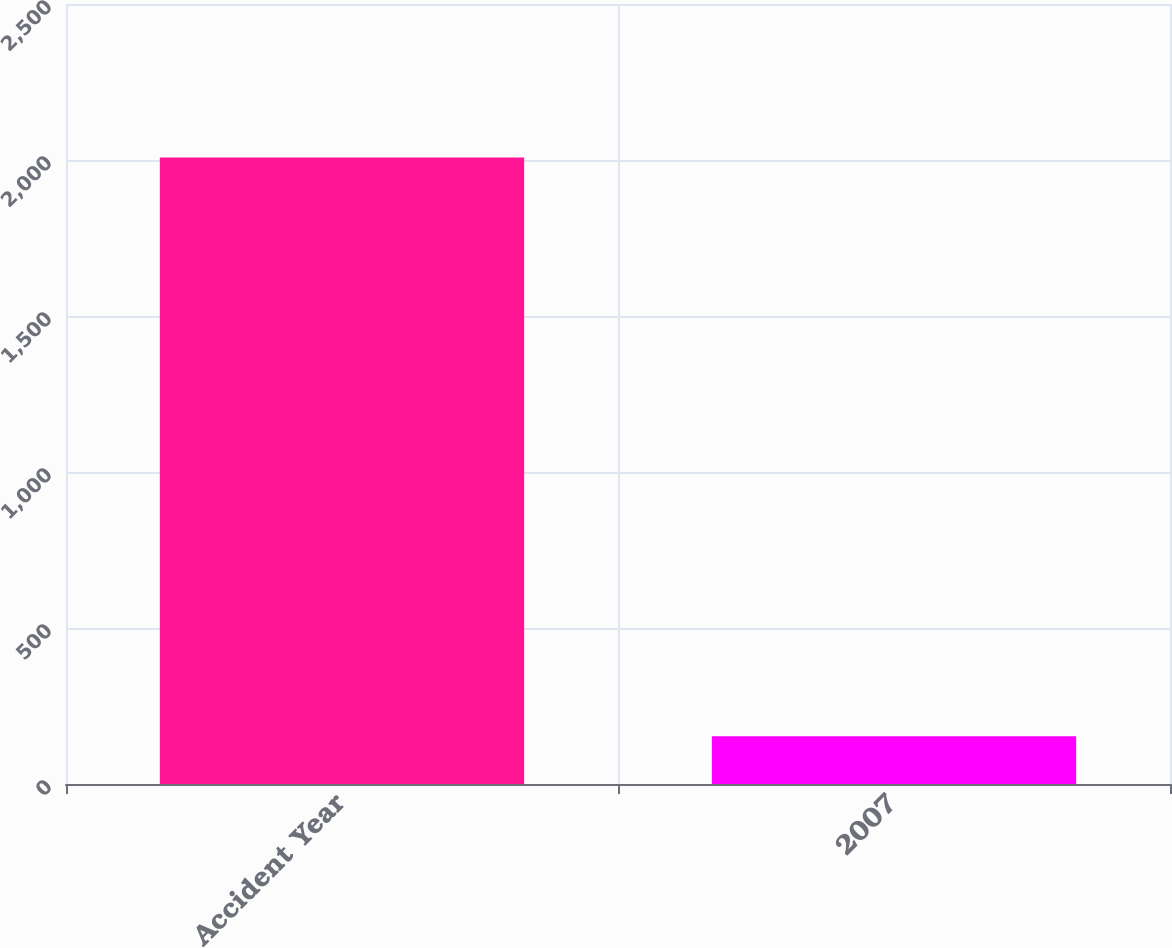<chart> <loc_0><loc_0><loc_500><loc_500><bar_chart><fcel>Accident Year<fcel>2007<nl><fcel>2008<fcel>153<nl></chart> 